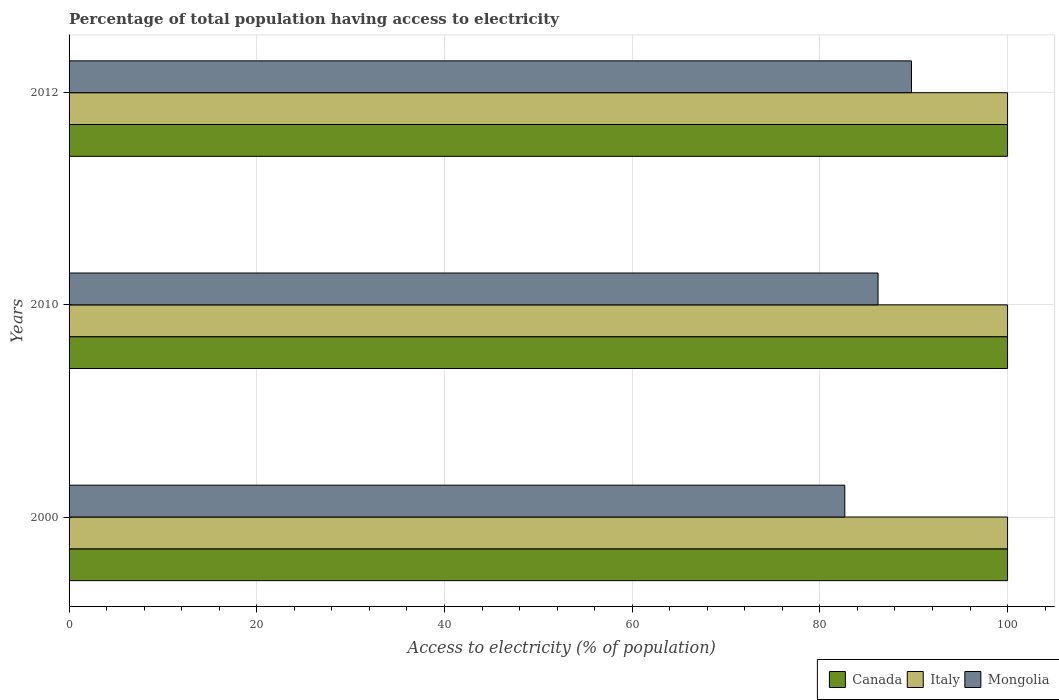Are the number of bars on each tick of the Y-axis equal?
Offer a terse response. Yes. How many bars are there on the 2nd tick from the top?
Keep it short and to the point. 3. What is the percentage of population that have access to electricity in Italy in 2000?
Keep it short and to the point. 100. Across all years, what is the maximum percentage of population that have access to electricity in Mongolia?
Your response must be concise. 89.76. Across all years, what is the minimum percentage of population that have access to electricity in Mongolia?
Your answer should be compact. 82.66. What is the total percentage of population that have access to electricity in Mongolia in the graph?
Keep it short and to the point. 258.62. What is the difference between the percentage of population that have access to electricity in Italy in 2010 and that in 2012?
Ensure brevity in your answer.  0. What is the difference between the percentage of population that have access to electricity in Canada in 2000 and the percentage of population that have access to electricity in Mongolia in 2012?
Your answer should be very brief. 10.24. What is the average percentage of population that have access to electricity in Mongolia per year?
Ensure brevity in your answer.  86.21. In the year 2010, what is the difference between the percentage of population that have access to electricity in Italy and percentage of population that have access to electricity in Mongolia?
Offer a terse response. 13.8. What is the ratio of the percentage of population that have access to electricity in Canada in 2000 to that in 2012?
Offer a terse response. 1. Is the percentage of population that have access to electricity in Italy in 2000 less than that in 2010?
Provide a short and direct response. No. What is the difference between the highest and the second highest percentage of population that have access to electricity in Mongolia?
Your answer should be very brief. 3.56. What is the difference between the highest and the lowest percentage of population that have access to electricity in Mongolia?
Provide a succinct answer. 7.11. What does the 1st bar from the top in 2010 represents?
Your answer should be very brief. Mongolia. What does the 1st bar from the bottom in 2012 represents?
Offer a very short reply. Canada. Is it the case that in every year, the sum of the percentage of population that have access to electricity in Mongolia and percentage of population that have access to electricity in Canada is greater than the percentage of population that have access to electricity in Italy?
Offer a terse response. Yes. How many bars are there?
Provide a short and direct response. 9. Are all the bars in the graph horizontal?
Your answer should be compact. Yes. What is the difference between two consecutive major ticks on the X-axis?
Make the answer very short. 20. Are the values on the major ticks of X-axis written in scientific E-notation?
Make the answer very short. No. Does the graph contain grids?
Keep it short and to the point. Yes. How many legend labels are there?
Offer a very short reply. 3. How are the legend labels stacked?
Your response must be concise. Horizontal. What is the title of the graph?
Your response must be concise. Percentage of total population having access to electricity. What is the label or title of the X-axis?
Provide a short and direct response. Access to electricity (% of population). What is the Access to electricity (% of population) in Mongolia in 2000?
Provide a short and direct response. 82.66. What is the Access to electricity (% of population) of Canada in 2010?
Ensure brevity in your answer.  100. What is the Access to electricity (% of population) in Italy in 2010?
Provide a succinct answer. 100. What is the Access to electricity (% of population) of Mongolia in 2010?
Provide a short and direct response. 86.2. What is the Access to electricity (% of population) in Italy in 2012?
Your response must be concise. 100. What is the Access to electricity (% of population) of Mongolia in 2012?
Give a very brief answer. 89.76. Across all years, what is the maximum Access to electricity (% of population) in Italy?
Provide a succinct answer. 100. Across all years, what is the maximum Access to electricity (% of population) of Mongolia?
Make the answer very short. 89.76. Across all years, what is the minimum Access to electricity (% of population) of Canada?
Provide a short and direct response. 100. Across all years, what is the minimum Access to electricity (% of population) of Italy?
Give a very brief answer. 100. Across all years, what is the minimum Access to electricity (% of population) in Mongolia?
Give a very brief answer. 82.66. What is the total Access to electricity (% of population) in Canada in the graph?
Offer a terse response. 300. What is the total Access to electricity (% of population) of Italy in the graph?
Make the answer very short. 300. What is the total Access to electricity (% of population) of Mongolia in the graph?
Your answer should be compact. 258.62. What is the difference between the Access to electricity (% of population) in Mongolia in 2000 and that in 2010?
Offer a very short reply. -3.54. What is the difference between the Access to electricity (% of population) in Canada in 2000 and that in 2012?
Offer a very short reply. 0. What is the difference between the Access to electricity (% of population) of Italy in 2000 and that in 2012?
Your response must be concise. 0. What is the difference between the Access to electricity (% of population) of Mongolia in 2000 and that in 2012?
Give a very brief answer. -7.11. What is the difference between the Access to electricity (% of population) in Canada in 2010 and that in 2012?
Your answer should be very brief. 0. What is the difference between the Access to electricity (% of population) in Italy in 2010 and that in 2012?
Your response must be concise. 0. What is the difference between the Access to electricity (% of population) of Mongolia in 2010 and that in 2012?
Offer a very short reply. -3.56. What is the difference between the Access to electricity (% of population) in Canada in 2000 and the Access to electricity (% of population) in Mongolia in 2010?
Your response must be concise. 13.8. What is the difference between the Access to electricity (% of population) of Canada in 2000 and the Access to electricity (% of population) of Mongolia in 2012?
Provide a succinct answer. 10.24. What is the difference between the Access to electricity (% of population) in Italy in 2000 and the Access to electricity (% of population) in Mongolia in 2012?
Make the answer very short. 10.24. What is the difference between the Access to electricity (% of population) of Canada in 2010 and the Access to electricity (% of population) of Mongolia in 2012?
Ensure brevity in your answer.  10.24. What is the difference between the Access to electricity (% of population) in Italy in 2010 and the Access to electricity (% of population) in Mongolia in 2012?
Keep it short and to the point. 10.24. What is the average Access to electricity (% of population) of Italy per year?
Provide a succinct answer. 100. What is the average Access to electricity (% of population) in Mongolia per year?
Provide a short and direct response. 86.21. In the year 2000, what is the difference between the Access to electricity (% of population) in Canada and Access to electricity (% of population) in Mongolia?
Make the answer very short. 17.34. In the year 2000, what is the difference between the Access to electricity (% of population) of Italy and Access to electricity (% of population) of Mongolia?
Provide a short and direct response. 17.34. In the year 2010, what is the difference between the Access to electricity (% of population) of Canada and Access to electricity (% of population) of Italy?
Offer a very short reply. 0. In the year 2012, what is the difference between the Access to electricity (% of population) of Canada and Access to electricity (% of population) of Mongolia?
Offer a very short reply. 10.24. In the year 2012, what is the difference between the Access to electricity (% of population) of Italy and Access to electricity (% of population) of Mongolia?
Your answer should be very brief. 10.24. What is the ratio of the Access to electricity (% of population) of Italy in 2000 to that in 2010?
Your answer should be compact. 1. What is the ratio of the Access to electricity (% of population) in Mongolia in 2000 to that in 2010?
Make the answer very short. 0.96. What is the ratio of the Access to electricity (% of population) in Italy in 2000 to that in 2012?
Offer a terse response. 1. What is the ratio of the Access to electricity (% of population) in Mongolia in 2000 to that in 2012?
Offer a very short reply. 0.92. What is the ratio of the Access to electricity (% of population) in Mongolia in 2010 to that in 2012?
Provide a succinct answer. 0.96. What is the difference between the highest and the second highest Access to electricity (% of population) of Canada?
Provide a succinct answer. 0. What is the difference between the highest and the second highest Access to electricity (% of population) of Italy?
Provide a succinct answer. 0. What is the difference between the highest and the second highest Access to electricity (% of population) in Mongolia?
Give a very brief answer. 3.56. What is the difference between the highest and the lowest Access to electricity (% of population) of Canada?
Give a very brief answer. 0. What is the difference between the highest and the lowest Access to electricity (% of population) in Italy?
Your answer should be compact. 0. What is the difference between the highest and the lowest Access to electricity (% of population) in Mongolia?
Provide a short and direct response. 7.11. 